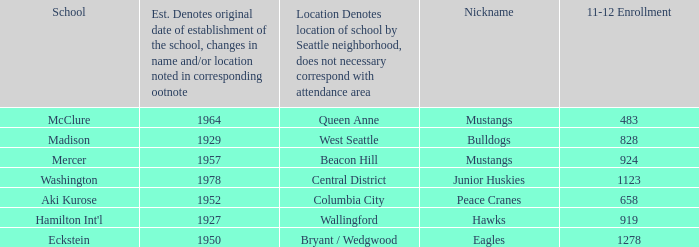Name the minimum 11-12 enrollment for washington school 1123.0. 